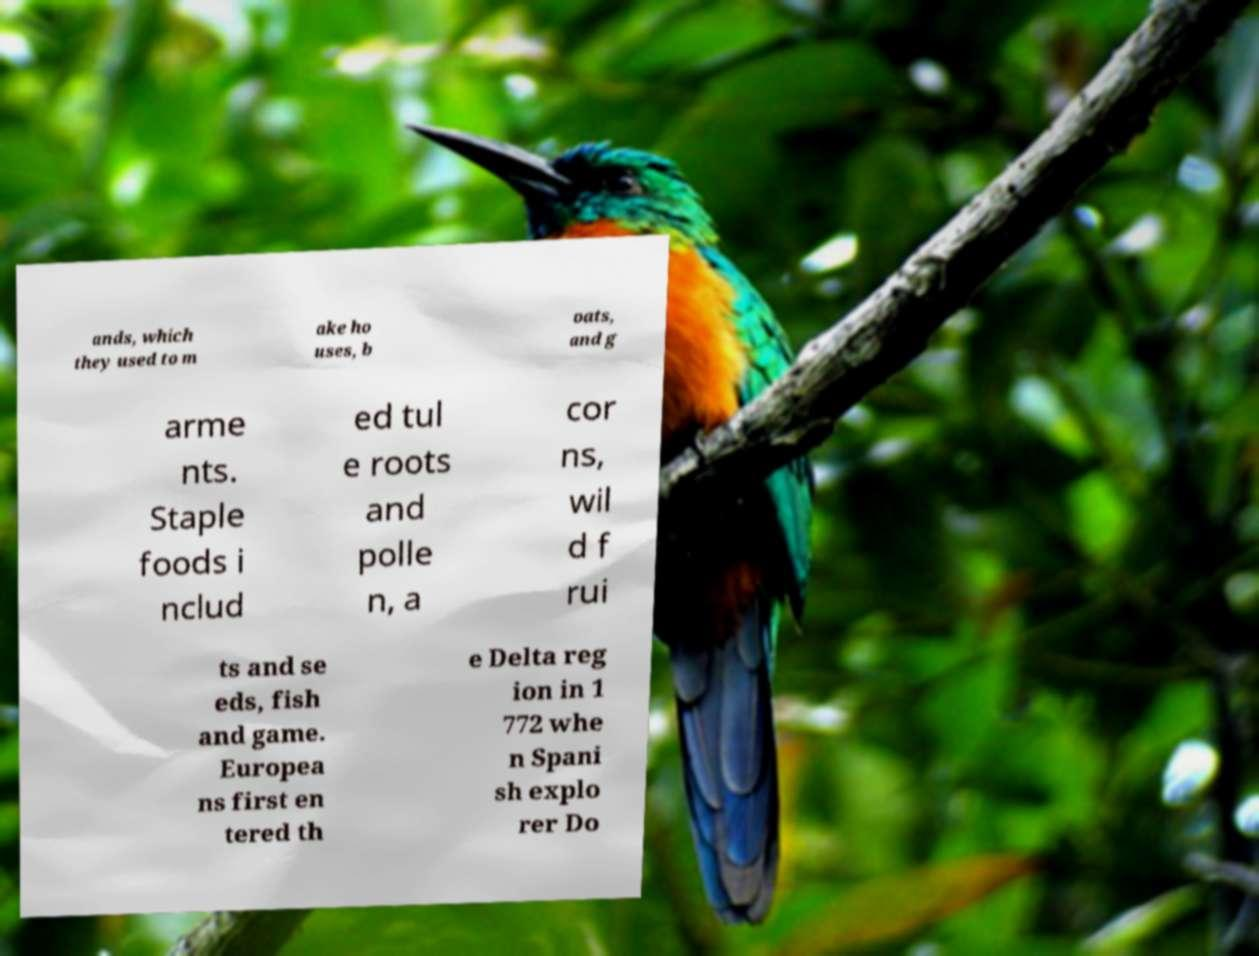Could you extract and type out the text from this image? ands, which they used to m ake ho uses, b oats, and g arme nts. Staple foods i nclud ed tul e roots and polle n, a cor ns, wil d f rui ts and se eds, fish and game. Europea ns first en tered th e Delta reg ion in 1 772 whe n Spani sh explo rer Do 